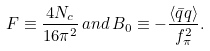<formula> <loc_0><loc_0><loc_500><loc_500>F \equiv \frac { 4 N _ { c } } { 1 6 \pi ^ { 2 } } \, a n d \, B _ { 0 } \equiv - \frac { \langle \bar { q } q \rangle } { f _ { \pi } ^ { 2 } } .</formula> 